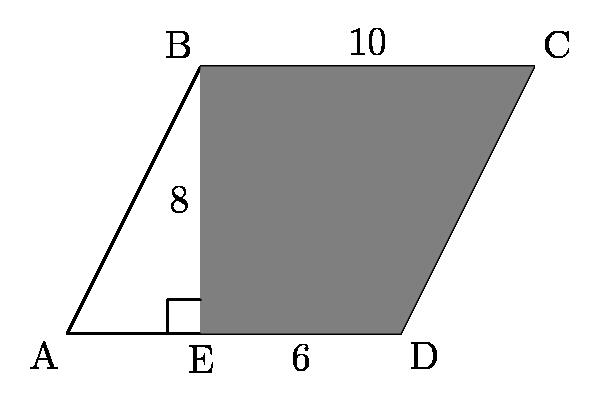Can you explain how the properties of a parallelogram are illustrated in this image? Certainly! In the image, parallelogram ABCD showcases the property that opposite sides are equal in length and parallel to each other. Sides AB and CD are a pair of opposite sides that appear to be parallel and of equal length, and the same applies to sides BC and AD. Another property observable in this image is that the opposite angles are equal, which although not marked, can be inferred from the shape. The image also indicates a right-angle at vertex E, which tells us that the height (EB) is perpendicular to the base (ED) of the parallelogram. 